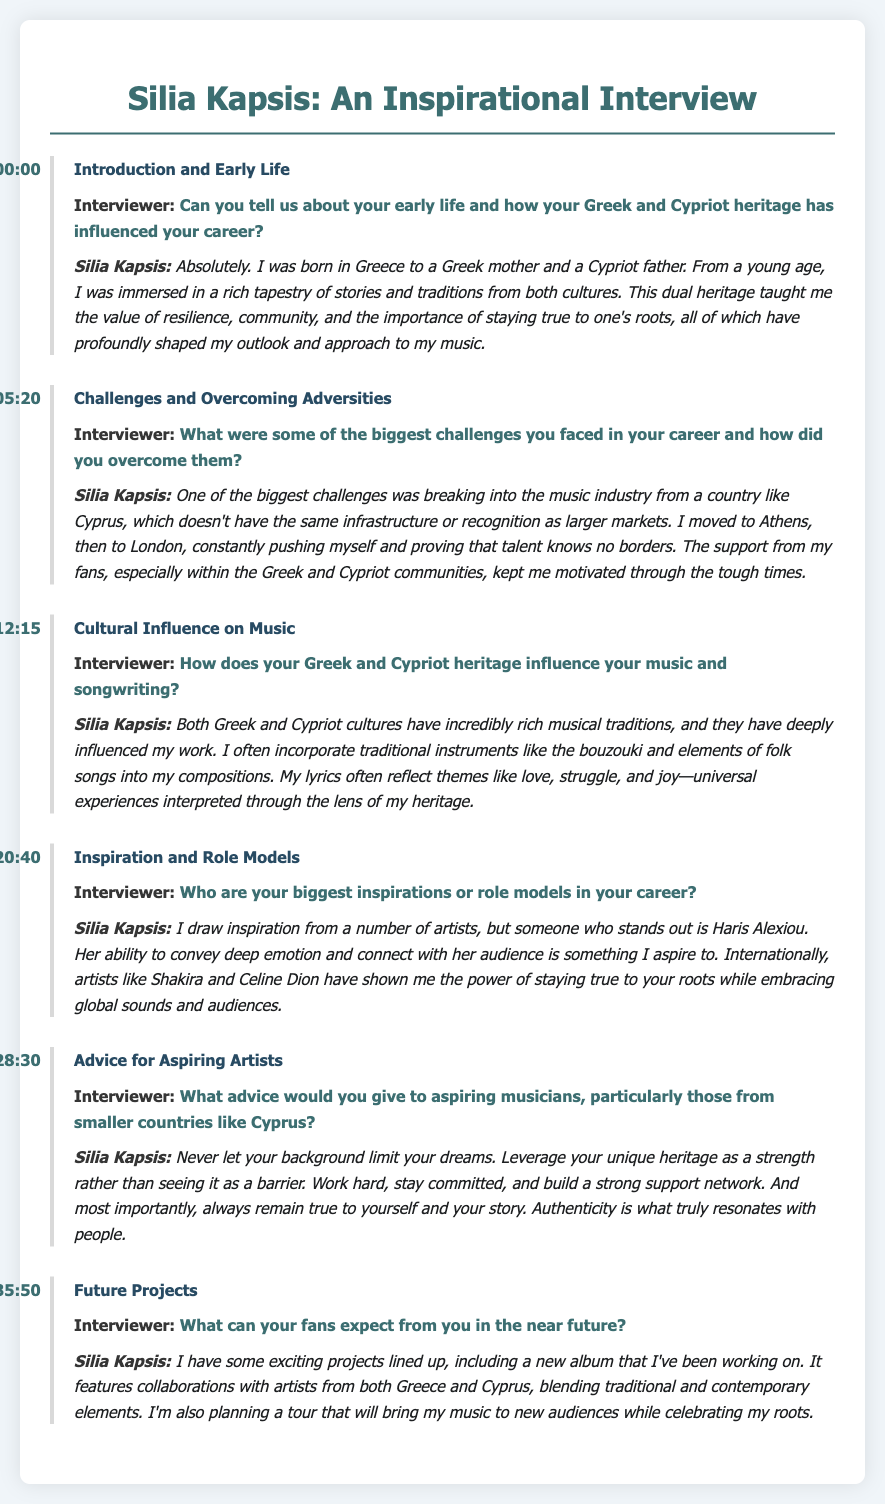What is Silia Kapsis's heritage? Silia Kapsis mentions she was born to a Greek mother and a Cypriot father, indicating her dual heritage.
Answer: Greek and Cypriot At what timestamp does Silia talk about inspiration and role models? The timestamp indicates when Silia mentions her inspirations, which is noted at the beginning of that section.
Answer: 20:40 What instrument does Silia Kapsis mention incorporating into her music? She refers to using traditional instruments in her music, specifically highlighting one that is commonly associated with Greek music.
Answer: Bouzouki Who is one of Silia's biggest inspirations? Silia highlights prominent artists who influence her, including someone from Greece well-known for her deep emotional connection through music.
Answer: Haris Alexiou What is the main advice Silia gives to aspiring musicians? Silia emphasizes a proactive approach to music careers, encouraging individuals to view their background as an advantage.
Answer: Never let your background limit your dreams What future project is Silia currently working on? During her interview, she shares details about upcoming creative efforts which include several collaborations.
Answer: A new album What themes does Silia's music often reflect? Silia discusses the universal nature of specific experiences that her lyrics capture, which is a key characteristic of her songwriting.
Answer: Love, struggle, and joy What city did Silia move to in order to pursue her career? Silia explains her journey of relocating to a major city to advance in the music industry, which is a significant part of her story.
Answer: Athens 